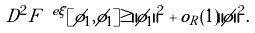<formula> <loc_0><loc_0><loc_500><loc_500>D ^ { 2 } F ^ { \ e \xi } [ \phi _ { 1 } , \phi _ { 1 } ] \geq \| \phi _ { 1 } \| ^ { 2 } + o _ { R } ( 1 ) \| \phi \| ^ { 2 } .</formula> 